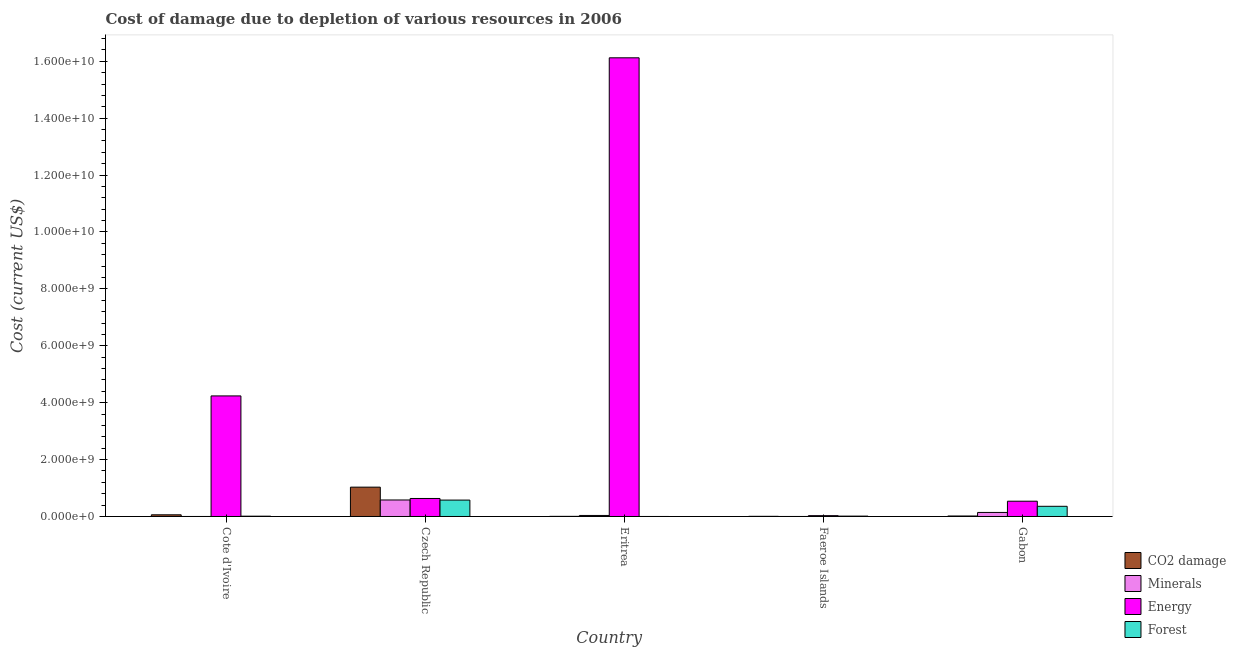How many different coloured bars are there?
Give a very brief answer. 4. How many groups of bars are there?
Your answer should be compact. 5. Are the number of bars per tick equal to the number of legend labels?
Your answer should be very brief. Yes. Are the number of bars on each tick of the X-axis equal?
Make the answer very short. Yes. How many bars are there on the 4th tick from the left?
Ensure brevity in your answer.  4. What is the label of the 1st group of bars from the left?
Offer a very short reply. Cote d'Ivoire. What is the cost of damage due to depletion of coal in Faeroe Islands?
Keep it short and to the point. 5.73e+06. Across all countries, what is the maximum cost of damage due to depletion of minerals?
Your answer should be compact. 5.80e+08. Across all countries, what is the minimum cost of damage due to depletion of energy?
Make the answer very short. 2.96e+07. In which country was the cost of damage due to depletion of minerals maximum?
Offer a very short reply. Czech Republic. In which country was the cost of damage due to depletion of energy minimum?
Your response must be concise. Faeroe Islands. What is the total cost of damage due to depletion of coal in the graph?
Provide a short and direct response. 1.12e+09. What is the difference between the cost of damage due to depletion of coal in Cote d'Ivoire and that in Faeroe Islands?
Keep it short and to the point. 5.33e+07. What is the difference between the cost of damage due to depletion of energy in Gabon and the cost of damage due to depletion of coal in Czech Republic?
Keep it short and to the point. -4.95e+08. What is the average cost of damage due to depletion of minerals per country?
Make the answer very short. 1.52e+08. What is the difference between the cost of damage due to depletion of minerals and cost of damage due to depletion of energy in Gabon?
Provide a short and direct response. -3.95e+08. What is the ratio of the cost of damage due to depletion of energy in Cote d'Ivoire to that in Faeroe Islands?
Provide a succinct answer. 143.39. Is the cost of damage due to depletion of coal in Czech Republic less than that in Gabon?
Make the answer very short. No. What is the difference between the highest and the second highest cost of damage due to depletion of coal?
Provide a short and direct response. 9.72e+08. What is the difference between the highest and the lowest cost of damage due to depletion of coal?
Your answer should be compact. 1.03e+09. In how many countries, is the cost of damage due to depletion of energy greater than the average cost of damage due to depletion of energy taken over all countries?
Your answer should be very brief. 1. What does the 1st bar from the left in Eritrea represents?
Provide a short and direct response. CO2 damage. What does the 2nd bar from the right in Czech Republic represents?
Give a very brief answer. Energy. Are all the bars in the graph horizontal?
Give a very brief answer. No. How many countries are there in the graph?
Provide a succinct answer. 5. Are the values on the major ticks of Y-axis written in scientific E-notation?
Keep it short and to the point. Yes. Does the graph contain grids?
Provide a short and direct response. No. Where does the legend appear in the graph?
Provide a succinct answer. Bottom right. How many legend labels are there?
Offer a terse response. 4. How are the legend labels stacked?
Your answer should be compact. Vertical. What is the title of the graph?
Give a very brief answer. Cost of damage due to depletion of various resources in 2006 . Does "Environmental sustainability" appear as one of the legend labels in the graph?
Offer a terse response. No. What is the label or title of the Y-axis?
Provide a succinct answer. Cost (current US$). What is the Cost (current US$) in CO2 damage in Cote d'Ivoire?
Keep it short and to the point. 5.91e+07. What is the Cost (current US$) of Minerals in Cote d'Ivoire?
Your answer should be compact. 3.76e+05. What is the Cost (current US$) in Energy in Cote d'Ivoire?
Make the answer very short. 4.24e+09. What is the Cost (current US$) of Forest in Cote d'Ivoire?
Ensure brevity in your answer.  1.09e+07. What is the Cost (current US$) in CO2 damage in Czech Republic?
Give a very brief answer. 1.03e+09. What is the Cost (current US$) in Minerals in Czech Republic?
Keep it short and to the point. 5.80e+08. What is the Cost (current US$) in Energy in Czech Republic?
Provide a succinct answer. 6.33e+08. What is the Cost (current US$) of Forest in Czech Republic?
Offer a very short reply. 5.77e+08. What is the Cost (current US$) of CO2 damage in Eritrea?
Give a very brief answer. 4.74e+06. What is the Cost (current US$) in Minerals in Eritrea?
Ensure brevity in your answer.  3.62e+07. What is the Cost (current US$) of Energy in Eritrea?
Give a very brief answer. 1.61e+1. What is the Cost (current US$) of Forest in Eritrea?
Your answer should be compact. 1.50e+05. What is the Cost (current US$) in CO2 damage in Faeroe Islands?
Keep it short and to the point. 5.73e+06. What is the Cost (current US$) of Minerals in Faeroe Islands?
Keep it short and to the point. 1.26e+05. What is the Cost (current US$) of Energy in Faeroe Islands?
Your answer should be very brief. 2.96e+07. What is the Cost (current US$) of Forest in Faeroe Islands?
Your response must be concise. 1.29e+07. What is the Cost (current US$) of CO2 damage in Gabon?
Offer a terse response. 1.76e+07. What is the Cost (current US$) of Minerals in Gabon?
Ensure brevity in your answer.  1.42e+08. What is the Cost (current US$) of Energy in Gabon?
Provide a short and direct response. 5.37e+08. What is the Cost (current US$) of Forest in Gabon?
Keep it short and to the point. 3.58e+08. Across all countries, what is the maximum Cost (current US$) of CO2 damage?
Your response must be concise. 1.03e+09. Across all countries, what is the maximum Cost (current US$) of Minerals?
Your answer should be compact. 5.80e+08. Across all countries, what is the maximum Cost (current US$) of Energy?
Make the answer very short. 1.61e+1. Across all countries, what is the maximum Cost (current US$) in Forest?
Your answer should be very brief. 5.77e+08. Across all countries, what is the minimum Cost (current US$) of CO2 damage?
Offer a terse response. 4.74e+06. Across all countries, what is the minimum Cost (current US$) in Minerals?
Offer a very short reply. 1.26e+05. Across all countries, what is the minimum Cost (current US$) of Energy?
Make the answer very short. 2.96e+07. Across all countries, what is the minimum Cost (current US$) in Forest?
Provide a succinct answer. 1.50e+05. What is the total Cost (current US$) in CO2 damage in the graph?
Keep it short and to the point. 1.12e+09. What is the total Cost (current US$) of Minerals in the graph?
Your response must be concise. 7.59e+08. What is the total Cost (current US$) in Energy in the graph?
Keep it short and to the point. 2.16e+1. What is the total Cost (current US$) of Forest in the graph?
Offer a very short reply. 9.58e+08. What is the difference between the Cost (current US$) in CO2 damage in Cote d'Ivoire and that in Czech Republic?
Your answer should be compact. -9.72e+08. What is the difference between the Cost (current US$) in Minerals in Cote d'Ivoire and that in Czech Republic?
Provide a short and direct response. -5.80e+08. What is the difference between the Cost (current US$) in Energy in Cote d'Ivoire and that in Czech Republic?
Provide a short and direct response. 3.60e+09. What is the difference between the Cost (current US$) of Forest in Cote d'Ivoire and that in Czech Republic?
Provide a short and direct response. -5.66e+08. What is the difference between the Cost (current US$) of CO2 damage in Cote d'Ivoire and that in Eritrea?
Provide a short and direct response. 5.43e+07. What is the difference between the Cost (current US$) in Minerals in Cote d'Ivoire and that in Eritrea?
Give a very brief answer. -3.59e+07. What is the difference between the Cost (current US$) of Energy in Cote d'Ivoire and that in Eritrea?
Your response must be concise. -1.19e+1. What is the difference between the Cost (current US$) of Forest in Cote d'Ivoire and that in Eritrea?
Keep it short and to the point. 1.07e+07. What is the difference between the Cost (current US$) of CO2 damage in Cote d'Ivoire and that in Faeroe Islands?
Keep it short and to the point. 5.33e+07. What is the difference between the Cost (current US$) of Minerals in Cote d'Ivoire and that in Faeroe Islands?
Provide a succinct answer. 2.50e+05. What is the difference between the Cost (current US$) in Energy in Cote d'Ivoire and that in Faeroe Islands?
Keep it short and to the point. 4.21e+09. What is the difference between the Cost (current US$) in Forest in Cote d'Ivoire and that in Faeroe Islands?
Your answer should be compact. -2.09e+06. What is the difference between the Cost (current US$) of CO2 damage in Cote d'Ivoire and that in Gabon?
Offer a terse response. 4.15e+07. What is the difference between the Cost (current US$) in Minerals in Cote d'Ivoire and that in Gabon?
Provide a short and direct response. -1.42e+08. What is the difference between the Cost (current US$) in Energy in Cote d'Ivoire and that in Gabon?
Your response must be concise. 3.70e+09. What is the difference between the Cost (current US$) in Forest in Cote d'Ivoire and that in Gabon?
Make the answer very short. -3.47e+08. What is the difference between the Cost (current US$) of CO2 damage in Czech Republic and that in Eritrea?
Offer a very short reply. 1.03e+09. What is the difference between the Cost (current US$) in Minerals in Czech Republic and that in Eritrea?
Offer a terse response. 5.44e+08. What is the difference between the Cost (current US$) in Energy in Czech Republic and that in Eritrea?
Provide a succinct answer. -1.55e+1. What is the difference between the Cost (current US$) of Forest in Czech Republic and that in Eritrea?
Your answer should be compact. 5.76e+08. What is the difference between the Cost (current US$) of CO2 damage in Czech Republic and that in Faeroe Islands?
Provide a succinct answer. 1.03e+09. What is the difference between the Cost (current US$) of Minerals in Czech Republic and that in Faeroe Islands?
Your response must be concise. 5.80e+08. What is the difference between the Cost (current US$) of Energy in Czech Republic and that in Faeroe Islands?
Offer a terse response. 6.03e+08. What is the difference between the Cost (current US$) of Forest in Czech Republic and that in Faeroe Islands?
Offer a very short reply. 5.64e+08. What is the difference between the Cost (current US$) of CO2 damage in Czech Republic and that in Gabon?
Make the answer very short. 1.01e+09. What is the difference between the Cost (current US$) in Minerals in Czech Republic and that in Gabon?
Provide a succinct answer. 4.38e+08. What is the difference between the Cost (current US$) in Energy in Czech Republic and that in Gabon?
Your response must be concise. 9.59e+07. What is the difference between the Cost (current US$) of Forest in Czech Republic and that in Gabon?
Make the answer very short. 2.19e+08. What is the difference between the Cost (current US$) of CO2 damage in Eritrea and that in Faeroe Islands?
Provide a succinct answer. -9.91e+05. What is the difference between the Cost (current US$) in Minerals in Eritrea and that in Faeroe Islands?
Your answer should be compact. 3.61e+07. What is the difference between the Cost (current US$) in Energy in Eritrea and that in Faeroe Islands?
Provide a short and direct response. 1.61e+1. What is the difference between the Cost (current US$) in Forest in Eritrea and that in Faeroe Islands?
Offer a very short reply. -1.28e+07. What is the difference between the Cost (current US$) of CO2 damage in Eritrea and that in Gabon?
Offer a very short reply. -1.28e+07. What is the difference between the Cost (current US$) of Minerals in Eritrea and that in Gabon?
Keep it short and to the point. -1.06e+08. What is the difference between the Cost (current US$) in Energy in Eritrea and that in Gabon?
Offer a terse response. 1.56e+1. What is the difference between the Cost (current US$) in Forest in Eritrea and that in Gabon?
Give a very brief answer. -3.58e+08. What is the difference between the Cost (current US$) in CO2 damage in Faeroe Islands and that in Gabon?
Offer a very short reply. -1.19e+07. What is the difference between the Cost (current US$) of Minerals in Faeroe Islands and that in Gabon?
Your answer should be compact. -1.42e+08. What is the difference between the Cost (current US$) in Energy in Faeroe Islands and that in Gabon?
Your response must be concise. -5.07e+08. What is the difference between the Cost (current US$) of Forest in Faeroe Islands and that in Gabon?
Offer a very short reply. -3.45e+08. What is the difference between the Cost (current US$) of CO2 damage in Cote d'Ivoire and the Cost (current US$) of Minerals in Czech Republic?
Offer a very short reply. -5.21e+08. What is the difference between the Cost (current US$) of CO2 damage in Cote d'Ivoire and the Cost (current US$) of Energy in Czech Republic?
Keep it short and to the point. -5.74e+08. What is the difference between the Cost (current US$) in CO2 damage in Cote d'Ivoire and the Cost (current US$) in Forest in Czech Republic?
Offer a very short reply. -5.17e+08. What is the difference between the Cost (current US$) of Minerals in Cote d'Ivoire and the Cost (current US$) of Energy in Czech Republic?
Make the answer very short. -6.32e+08. What is the difference between the Cost (current US$) of Minerals in Cote d'Ivoire and the Cost (current US$) of Forest in Czech Republic?
Your response must be concise. -5.76e+08. What is the difference between the Cost (current US$) in Energy in Cote d'Ivoire and the Cost (current US$) in Forest in Czech Republic?
Your answer should be very brief. 3.66e+09. What is the difference between the Cost (current US$) of CO2 damage in Cote d'Ivoire and the Cost (current US$) of Minerals in Eritrea?
Your answer should be compact. 2.28e+07. What is the difference between the Cost (current US$) of CO2 damage in Cote d'Ivoire and the Cost (current US$) of Energy in Eritrea?
Your answer should be very brief. -1.61e+1. What is the difference between the Cost (current US$) in CO2 damage in Cote d'Ivoire and the Cost (current US$) in Forest in Eritrea?
Ensure brevity in your answer.  5.89e+07. What is the difference between the Cost (current US$) in Minerals in Cote d'Ivoire and the Cost (current US$) in Energy in Eritrea?
Give a very brief answer. -1.61e+1. What is the difference between the Cost (current US$) of Minerals in Cote d'Ivoire and the Cost (current US$) of Forest in Eritrea?
Make the answer very short. 2.26e+05. What is the difference between the Cost (current US$) in Energy in Cote d'Ivoire and the Cost (current US$) in Forest in Eritrea?
Ensure brevity in your answer.  4.24e+09. What is the difference between the Cost (current US$) in CO2 damage in Cote d'Ivoire and the Cost (current US$) in Minerals in Faeroe Islands?
Your answer should be compact. 5.89e+07. What is the difference between the Cost (current US$) of CO2 damage in Cote d'Ivoire and the Cost (current US$) of Energy in Faeroe Islands?
Your answer should be very brief. 2.95e+07. What is the difference between the Cost (current US$) of CO2 damage in Cote d'Ivoire and the Cost (current US$) of Forest in Faeroe Islands?
Offer a very short reply. 4.61e+07. What is the difference between the Cost (current US$) of Minerals in Cote d'Ivoire and the Cost (current US$) of Energy in Faeroe Islands?
Keep it short and to the point. -2.92e+07. What is the difference between the Cost (current US$) of Minerals in Cote d'Ivoire and the Cost (current US$) of Forest in Faeroe Islands?
Your answer should be very brief. -1.26e+07. What is the difference between the Cost (current US$) in Energy in Cote d'Ivoire and the Cost (current US$) in Forest in Faeroe Islands?
Offer a terse response. 4.22e+09. What is the difference between the Cost (current US$) in CO2 damage in Cote d'Ivoire and the Cost (current US$) in Minerals in Gabon?
Your answer should be compact. -8.32e+07. What is the difference between the Cost (current US$) in CO2 damage in Cote d'Ivoire and the Cost (current US$) in Energy in Gabon?
Your answer should be compact. -4.78e+08. What is the difference between the Cost (current US$) of CO2 damage in Cote d'Ivoire and the Cost (current US$) of Forest in Gabon?
Your answer should be very brief. -2.99e+08. What is the difference between the Cost (current US$) of Minerals in Cote d'Ivoire and the Cost (current US$) of Energy in Gabon?
Make the answer very short. -5.36e+08. What is the difference between the Cost (current US$) of Minerals in Cote d'Ivoire and the Cost (current US$) of Forest in Gabon?
Your answer should be compact. -3.57e+08. What is the difference between the Cost (current US$) in Energy in Cote d'Ivoire and the Cost (current US$) in Forest in Gabon?
Offer a very short reply. 3.88e+09. What is the difference between the Cost (current US$) of CO2 damage in Czech Republic and the Cost (current US$) of Minerals in Eritrea?
Give a very brief answer. 9.95e+08. What is the difference between the Cost (current US$) in CO2 damage in Czech Republic and the Cost (current US$) in Energy in Eritrea?
Offer a terse response. -1.51e+1. What is the difference between the Cost (current US$) of CO2 damage in Czech Republic and the Cost (current US$) of Forest in Eritrea?
Ensure brevity in your answer.  1.03e+09. What is the difference between the Cost (current US$) in Minerals in Czech Republic and the Cost (current US$) in Energy in Eritrea?
Your answer should be compact. -1.55e+1. What is the difference between the Cost (current US$) of Minerals in Czech Republic and the Cost (current US$) of Forest in Eritrea?
Make the answer very short. 5.80e+08. What is the difference between the Cost (current US$) in Energy in Czech Republic and the Cost (current US$) in Forest in Eritrea?
Provide a succinct answer. 6.33e+08. What is the difference between the Cost (current US$) in CO2 damage in Czech Republic and the Cost (current US$) in Minerals in Faeroe Islands?
Provide a short and direct response. 1.03e+09. What is the difference between the Cost (current US$) of CO2 damage in Czech Republic and the Cost (current US$) of Energy in Faeroe Islands?
Your response must be concise. 1.00e+09. What is the difference between the Cost (current US$) of CO2 damage in Czech Republic and the Cost (current US$) of Forest in Faeroe Islands?
Offer a very short reply. 1.02e+09. What is the difference between the Cost (current US$) of Minerals in Czech Republic and the Cost (current US$) of Energy in Faeroe Islands?
Make the answer very short. 5.51e+08. What is the difference between the Cost (current US$) in Minerals in Czech Republic and the Cost (current US$) in Forest in Faeroe Islands?
Keep it short and to the point. 5.68e+08. What is the difference between the Cost (current US$) in Energy in Czech Republic and the Cost (current US$) in Forest in Faeroe Islands?
Keep it short and to the point. 6.20e+08. What is the difference between the Cost (current US$) of CO2 damage in Czech Republic and the Cost (current US$) of Minerals in Gabon?
Your answer should be very brief. 8.89e+08. What is the difference between the Cost (current US$) in CO2 damage in Czech Republic and the Cost (current US$) in Energy in Gabon?
Your answer should be compact. 4.95e+08. What is the difference between the Cost (current US$) of CO2 damage in Czech Republic and the Cost (current US$) of Forest in Gabon?
Give a very brief answer. 6.74e+08. What is the difference between the Cost (current US$) in Minerals in Czech Republic and the Cost (current US$) in Energy in Gabon?
Make the answer very short. 4.37e+07. What is the difference between the Cost (current US$) of Minerals in Czech Republic and the Cost (current US$) of Forest in Gabon?
Offer a very short reply. 2.23e+08. What is the difference between the Cost (current US$) of Energy in Czech Republic and the Cost (current US$) of Forest in Gabon?
Your answer should be compact. 2.75e+08. What is the difference between the Cost (current US$) in CO2 damage in Eritrea and the Cost (current US$) in Minerals in Faeroe Islands?
Offer a very short reply. 4.61e+06. What is the difference between the Cost (current US$) of CO2 damage in Eritrea and the Cost (current US$) of Energy in Faeroe Islands?
Ensure brevity in your answer.  -2.48e+07. What is the difference between the Cost (current US$) of CO2 damage in Eritrea and the Cost (current US$) of Forest in Faeroe Islands?
Your response must be concise. -8.21e+06. What is the difference between the Cost (current US$) of Minerals in Eritrea and the Cost (current US$) of Energy in Faeroe Islands?
Your answer should be very brief. 6.67e+06. What is the difference between the Cost (current US$) of Minerals in Eritrea and the Cost (current US$) of Forest in Faeroe Islands?
Make the answer very short. 2.33e+07. What is the difference between the Cost (current US$) of Energy in Eritrea and the Cost (current US$) of Forest in Faeroe Islands?
Make the answer very short. 1.61e+1. What is the difference between the Cost (current US$) of CO2 damage in Eritrea and the Cost (current US$) of Minerals in Gabon?
Provide a succinct answer. -1.38e+08. What is the difference between the Cost (current US$) of CO2 damage in Eritrea and the Cost (current US$) of Energy in Gabon?
Provide a succinct answer. -5.32e+08. What is the difference between the Cost (current US$) of CO2 damage in Eritrea and the Cost (current US$) of Forest in Gabon?
Provide a short and direct response. -3.53e+08. What is the difference between the Cost (current US$) in Minerals in Eritrea and the Cost (current US$) in Energy in Gabon?
Provide a succinct answer. -5.01e+08. What is the difference between the Cost (current US$) in Minerals in Eritrea and the Cost (current US$) in Forest in Gabon?
Offer a terse response. -3.21e+08. What is the difference between the Cost (current US$) of Energy in Eritrea and the Cost (current US$) of Forest in Gabon?
Offer a very short reply. 1.58e+1. What is the difference between the Cost (current US$) in CO2 damage in Faeroe Islands and the Cost (current US$) in Minerals in Gabon?
Provide a succinct answer. -1.37e+08. What is the difference between the Cost (current US$) in CO2 damage in Faeroe Islands and the Cost (current US$) in Energy in Gabon?
Your answer should be very brief. -5.31e+08. What is the difference between the Cost (current US$) in CO2 damage in Faeroe Islands and the Cost (current US$) in Forest in Gabon?
Provide a short and direct response. -3.52e+08. What is the difference between the Cost (current US$) in Minerals in Faeroe Islands and the Cost (current US$) in Energy in Gabon?
Your answer should be very brief. -5.37e+08. What is the difference between the Cost (current US$) of Minerals in Faeroe Islands and the Cost (current US$) of Forest in Gabon?
Give a very brief answer. -3.58e+08. What is the difference between the Cost (current US$) in Energy in Faeroe Islands and the Cost (current US$) in Forest in Gabon?
Your answer should be very brief. -3.28e+08. What is the average Cost (current US$) in CO2 damage per country?
Your answer should be very brief. 2.24e+08. What is the average Cost (current US$) in Minerals per country?
Offer a very short reply. 1.52e+08. What is the average Cost (current US$) in Energy per country?
Offer a very short reply. 4.31e+09. What is the average Cost (current US$) of Forest per country?
Offer a terse response. 1.92e+08. What is the difference between the Cost (current US$) in CO2 damage and Cost (current US$) in Minerals in Cote d'Ivoire?
Provide a succinct answer. 5.87e+07. What is the difference between the Cost (current US$) of CO2 damage and Cost (current US$) of Energy in Cote d'Ivoire?
Provide a short and direct response. -4.18e+09. What is the difference between the Cost (current US$) in CO2 damage and Cost (current US$) in Forest in Cote d'Ivoire?
Provide a short and direct response. 4.82e+07. What is the difference between the Cost (current US$) in Minerals and Cost (current US$) in Energy in Cote d'Ivoire?
Provide a succinct answer. -4.24e+09. What is the difference between the Cost (current US$) of Minerals and Cost (current US$) of Forest in Cote d'Ivoire?
Provide a short and direct response. -1.05e+07. What is the difference between the Cost (current US$) in Energy and Cost (current US$) in Forest in Cote d'Ivoire?
Your answer should be compact. 4.23e+09. What is the difference between the Cost (current US$) of CO2 damage and Cost (current US$) of Minerals in Czech Republic?
Your answer should be compact. 4.51e+08. What is the difference between the Cost (current US$) in CO2 damage and Cost (current US$) in Energy in Czech Republic?
Offer a terse response. 3.99e+08. What is the difference between the Cost (current US$) of CO2 damage and Cost (current US$) of Forest in Czech Republic?
Provide a short and direct response. 4.55e+08. What is the difference between the Cost (current US$) of Minerals and Cost (current US$) of Energy in Czech Republic?
Offer a terse response. -5.23e+07. What is the difference between the Cost (current US$) in Minerals and Cost (current US$) in Forest in Czech Republic?
Provide a short and direct response. 3.95e+06. What is the difference between the Cost (current US$) in Energy and Cost (current US$) in Forest in Czech Republic?
Provide a short and direct response. 5.62e+07. What is the difference between the Cost (current US$) of CO2 damage and Cost (current US$) of Minerals in Eritrea?
Provide a succinct answer. -3.15e+07. What is the difference between the Cost (current US$) in CO2 damage and Cost (current US$) in Energy in Eritrea?
Your answer should be very brief. -1.61e+1. What is the difference between the Cost (current US$) in CO2 damage and Cost (current US$) in Forest in Eritrea?
Offer a very short reply. 4.59e+06. What is the difference between the Cost (current US$) in Minerals and Cost (current US$) in Energy in Eritrea?
Provide a short and direct response. -1.61e+1. What is the difference between the Cost (current US$) in Minerals and Cost (current US$) in Forest in Eritrea?
Provide a short and direct response. 3.61e+07. What is the difference between the Cost (current US$) in Energy and Cost (current US$) in Forest in Eritrea?
Offer a very short reply. 1.61e+1. What is the difference between the Cost (current US$) of CO2 damage and Cost (current US$) of Minerals in Faeroe Islands?
Offer a terse response. 5.60e+06. What is the difference between the Cost (current US$) in CO2 damage and Cost (current US$) in Energy in Faeroe Islands?
Keep it short and to the point. -2.38e+07. What is the difference between the Cost (current US$) in CO2 damage and Cost (current US$) in Forest in Faeroe Islands?
Provide a succinct answer. -7.22e+06. What is the difference between the Cost (current US$) in Minerals and Cost (current US$) in Energy in Faeroe Islands?
Ensure brevity in your answer.  -2.94e+07. What is the difference between the Cost (current US$) in Minerals and Cost (current US$) in Forest in Faeroe Islands?
Keep it short and to the point. -1.28e+07. What is the difference between the Cost (current US$) of Energy and Cost (current US$) of Forest in Faeroe Islands?
Offer a very short reply. 1.66e+07. What is the difference between the Cost (current US$) of CO2 damage and Cost (current US$) of Minerals in Gabon?
Offer a very short reply. -1.25e+08. What is the difference between the Cost (current US$) in CO2 damage and Cost (current US$) in Energy in Gabon?
Your answer should be compact. -5.19e+08. What is the difference between the Cost (current US$) in CO2 damage and Cost (current US$) in Forest in Gabon?
Give a very brief answer. -3.40e+08. What is the difference between the Cost (current US$) of Minerals and Cost (current US$) of Energy in Gabon?
Your answer should be very brief. -3.95e+08. What is the difference between the Cost (current US$) of Minerals and Cost (current US$) of Forest in Gabon?
Provide a short and direct response. -2.15e+08. What is the difference between the Cost (current US$) in Energy and Cost (current US$) in Forest in Gabon?
Your answer should be very brief. 1.79e+08. What is the ratio of the Cost (current US$) of CO2 damage in Cote d'Ivoire to that in Czech Republic?
Offer a terse response. 0.06. What is the ratio of the Cost (current US$) of Minerals in Cote d'Ivoire to that in Czech Republic?
Your response must be concise. 0. What is the ratio of the Cost (current US$) of Energy in Cote d'Ivoire to that in Czech Republic?
Your answer should be very brief. 6.7. What is the ratio of the Cost (current US$) of Forest in Cote d'Ivoire to that in Czech Republic?
Your answer should be compact. 0.02. What is the ratio of the Cost (current US$) in CO2 damage in Cote d'Ivoire to that in Eritrea?
Ensure brevity in your answer.  12.47. What is the ratio of the Cost (current US$) in Minerals in Cote d'Ivoire to that in Eritrea?
Your response must be concise. 0.01. What is the ratio of the Cost (current US$) in Energy in Cote d'Ivoire to that in Eritrea?
Offer a very short reply. 0.26. What is the ratio of the Cost (current US$) of Forest in Cote d'Ivoire to that in Eritrea?
Offer a very short reply. 72.37. What is the ratio of the Cost (current US$) of CO2 damage in Cote d'Ivoire to that in Faeroe Islands?
Give a very brief answer. 10.31. What is the ratio of the Cost (current US$) in Minerals in Cote d'Ivoire to that in Faeroe Islands?
Offer a terse response. 2.98. What is the ratio of the Cost (current US$) in Energy in Cote d'Ivoire to that in Faeroe Islands?
Your answer should be compact. 143.39. What is the ratio of the Cost (current US$) in Forest in Cote d'Ivoire to that in Faeroe Islands?
Offer a very short reply. 0.84. What is the ratio of the Cost (current US$) in CO2 damage in Cote d'Ivoire to that in Gabon?
Offer a very short reply. 3.36. What is the ratio of the Cost (current US$) of Minerals in Cote d'Ivoire to that in Gabon?
Your response must be concise. 0. What is the ratio of the Cost (current US$) in Energy in Cote d'Ivoire to that in Gabon?
Give a very brief answer. 7.89. What is the ratio of the Cost (current US$) in Forest in Cote d'Ivoire to that in Gabon?
Offer a terse response. 0.03. What is the ratio of the Cost (current US$) of CO2 damage in Czech Republic to that in Eritrea?
Your answer should be very brief. 217.74. What is the ratio of the Cost (current US$) of Minerals in Czech Republic to that in Eritrea?
Make the answer very short. 16.02. What is the ratio of the Cost (current US$) in Energy in Czech Republic to that in Eritrea?
Your answer should be compact. 0.04. What is the ratio of the Cost (current US$) in Forest in Czech Republic to that in Eritrea?
Make the answer very short. 3843.22. What is the ratio of the Cost (current US$) of CO2 damage in Czech Republic to that in Faeroe Islands?
Ensure brevity in your answer.  180.08. What is the ratio of the Cost (current US$) of Minerals in Czech Republic to that in Faeroe Islands?
Your answer should be compact. 4598.77. What is the ratio of the Cost (current US$) of Energy in Czech Republic to that in Faeroe Islands?
Your answer should be very brief. 21.41. What is the ratio of the Cost (current US$) of Forest in Czech Republic to that in Faeroe Islands?
Offer a terse response. 44.55. What is the ratio of the Cost (current US$) in CO2 damage in Czech Republic to that in Gabon?
Give a very brief answer. 58.65. What is the ratio of the Cost (current US$) in Minerals in Czech Republic to that in Gabon?
Offer a very short reply. 4.08. What is the ratio of the Cost (current US$) of Energy in Czech Republic to that in Gabon?
Keep it short and to the point. 1.18. What is the ratio of the Cost (current US$) of Forest in Czech Republic to that in Gabon?
Your answer should be very brief. 1.61. What is the ratio of the Cost (current US$) in CO2 damage in Eritrea to that in Faeroe Islands?
Your answer should be very brief. 0.83. What is the ratio of the Cost (current US$) of Minerals in Eritrea to that in Faeroe Islands?
Your answer should be very brief. 287.02. What is the ratio of the Cost (current US$) of Energy in Eritrea to that in Faeroe Islands?
Offer a very short reply. 545.48. What is the ratio of the Cost (current US$) in Forest in Eritrea to that in Faeroe Islands?
Your answer should be compact. 0.01. What is the ratio of the Cost (current US$) of CO2 damage in Eritrea to that in Gabon?
Your answer should be compact. 0.27. What is the ratio of the Cost (current US$) in Minerals in Eritrea to that in Gabon?
Provide a succinct answer. 0.25. What is the ratio of the Cost (current US$) of Energy in Eritrea to that in Gabon?
Provide a short and direct response. 30.03. What is the ratio of the Cost (current US$) in CO2 damage in Faeroe Islands to that in Gabon?
Ensure brevity in your answer.  0.33. What is the ratio of the Cost (current US$) in Minerals in Faeroe Islands to that in Gabon?
Your answer should be compact. 0. What is the ratio of the Cost (current US$) in Energy in Faeroe Islands to that in Gabon?
Offer a very short reply. 0.06. What is the ratio of the Cost (current US$) of Forest in Faeroe Islands to that in Gabon?
Your answer should be very brief. 0.04. What is the difference between the highest and the second highest Cost (current US$) in CO2 damage?
Your answer should be very brief. 9.72e+08. What is the difference between the highest and the second highest Cost (current US$) of Minerals?
Keep it short and to the point. 4.38e+08. What is the difference between the highest and the second highest Cost (current US$) in Energy?
Offer a terse response. 1.19e+1. What is the difference between the highest and the second highest Cost (current US$) of Forest?
Make the answer very short. 2.19e+08. What is the difference between the highest and the lowest Cost (current US$) of CO2 damage?
Give a very brief answer. 1.03e+09. What is the difference between the highest and the lowest Cost (current US$) in Minerals?
Offer a very short reply. 5.80e+08. What is the difference between the highest and the lowest Cost (current US$) in Energy?
Provide a succinct answer. 1.61e+1. What is the difference between the highest and the lowest Cost (current US$) of Forest?
Your answer should be very brief. 5.76e+08. 